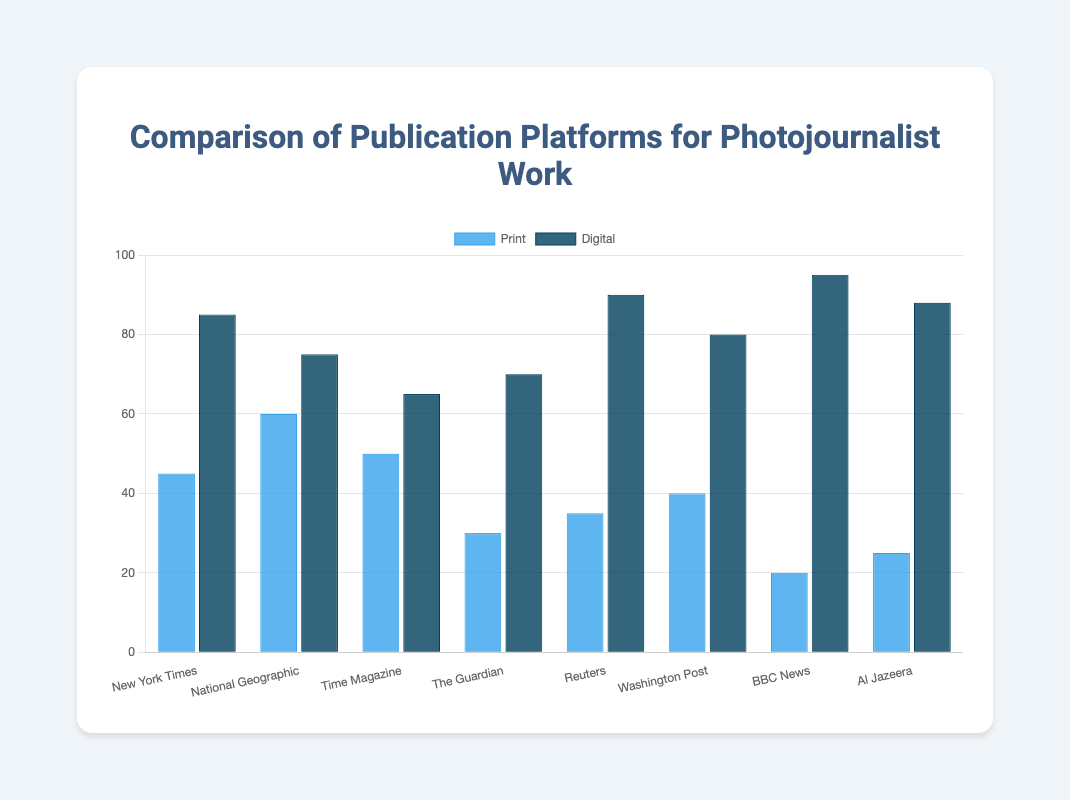Which platform has the highest value for digital publications? The highest bar in the 'Digital' category is for BBC News at 95.
Answer: BBC News Which platform has the lowest value for print publications? The smallest bar in the 'Print' category is for BBC News at 20.
Answer: BBC News What is the difference between the digital and print publications for Reuters? Identify the digital (90) and print (35) values for Reuters, then find the difference: 90 - 35 = 55.
Answer: 55 How many platforms have higher digital values than print values? Compare the heights of the bars for each platform in the 'Digital' and 'Print' categories. All 8 platforms have higher digital values than print values.
Answer: 8 What is the average number of print publications for all platforms? Sum the print values (45 + 60 + 50 + 30 + 35 + 40 + 20 + 25 = 305) and divide by the number of platforms (8). 305 / 8 = 38.125.
Answer: 38.125 Which platform has the smallest difference between print and digital publications? Calculate the differences for each platform and find the smallest: NYT (40), NG (15), TM (15), TG (40), R (55), WP (40), BN (75), AJ (63). National Geographic and Time Magazine have the smallest difference of 15.
Answer: National Geographic & Time Magazine What is the total number of digital publications for all platforms combined? Sum the digital values: 85 + 75 + 65 + 70 + 90 + 80 + 95 + 88 = 648.
Answer: 648 Which platform shows the largest increase in publications from print to digital? Identify the differences between digital and print for each platform and find the largest: NYT (40), NG (15), TM (15), TG (40), R (55), WP (40), BN (75), AJ (63). BBC News has the largest increase of 75.
Answer: BBC News What percentage of total print publications do the New York Times and National Geographic account for combined? Sum the print values for NYT and NG (45 + 60 = 105), then find the percentage of the total print sum (305). (105 / 305) * 100 ≈ 34.43%.
Answer: 34.43% Compare and analyze the publications for The Guardian and Washington Post. Which platform has more digital publications, and are their print numbers significantly different? The Guardian has 70 digital publications, while the Washington Post has 80. Washington Post has more digital publications. The print values are 30 (Guardian) and 40 (Washington Post), a difference of 10.
Answer: Washington Post; Yes, by 10 